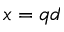Convert formula to latex. <formula><loc_0><loc_0><loc_500><loc_500>x = q d</formula> 